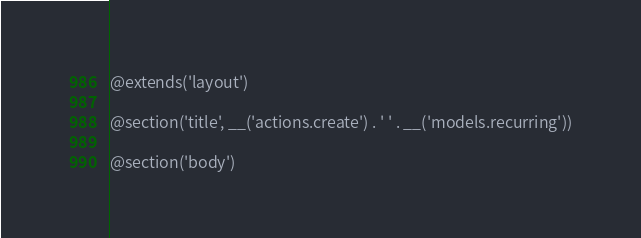<code> <loc_0><loc_0><loc_500><loc_500><_PHP_>@extends('layout')

@section('title', __('actions.create') . ' ' . __('models.recurring'))

@section('body')</code> 